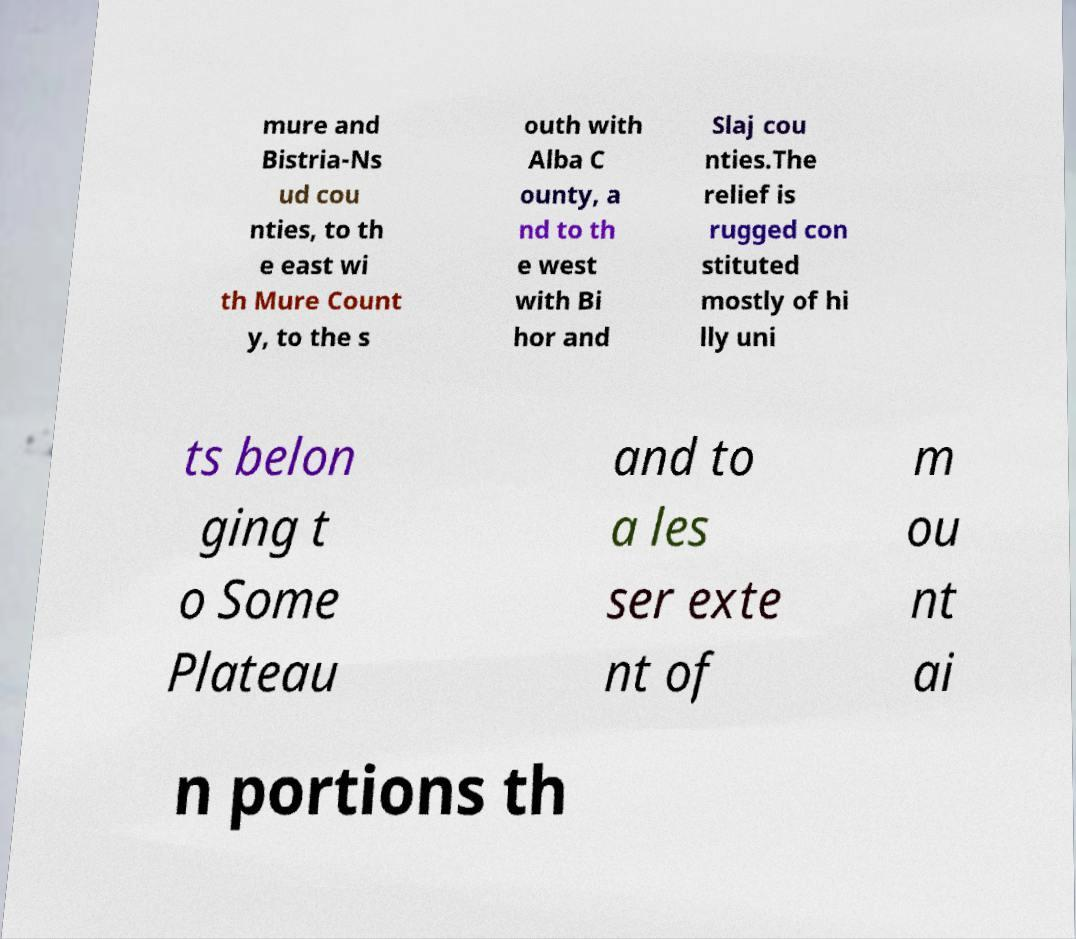There's text embedded in this image that I need extracted. Can you transcribe it verbatim? mure and Bistria-Ns ud cou nties, to th e east wi th Mure Count y, to the s outh with Alba C ounty, a nd to th e west with Bi hor and Slaj cou nties.The relief is rugged con stituted mostly of hi lly uni ts belon ging t o Some Plateau and to a les ser exte nt of m ou nt ai n portions th 